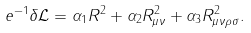Convert formula to latex. <formula><loc_0><loc_0><loc_500><loc_500>e ^ { - 1 } \delta \mathcal { L } = \alpha _ { 1 } R ^ { 2 } + \alpha _ { 2 } R _ { \mu \nu } ^ { 2 } + \alpha _ { 3 } R _ { \mu \nu \rho \sigma } ^ { 2 } .</formula> 